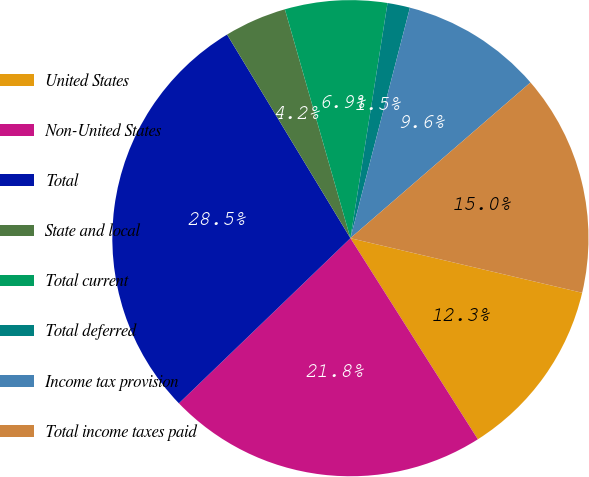Convert chart to OTSL. <chart><loc_0><loc_0><loc_500><loc_500><pie_chart><fcel>United States<fcel>Non-United States<fcel>Total<fcel>State and local<fcel>Total current<fcel>Total deferred<fcel>Income tax provision<fcel>Total income taxes paid<nl><fcel>12.33%<fcel>21.79%<fcel>28.53%<fcel>4.23%<fcel>6.93%<fcel>1.53%<fcel>9.63%<fcel>15.03%<nl></chart> 